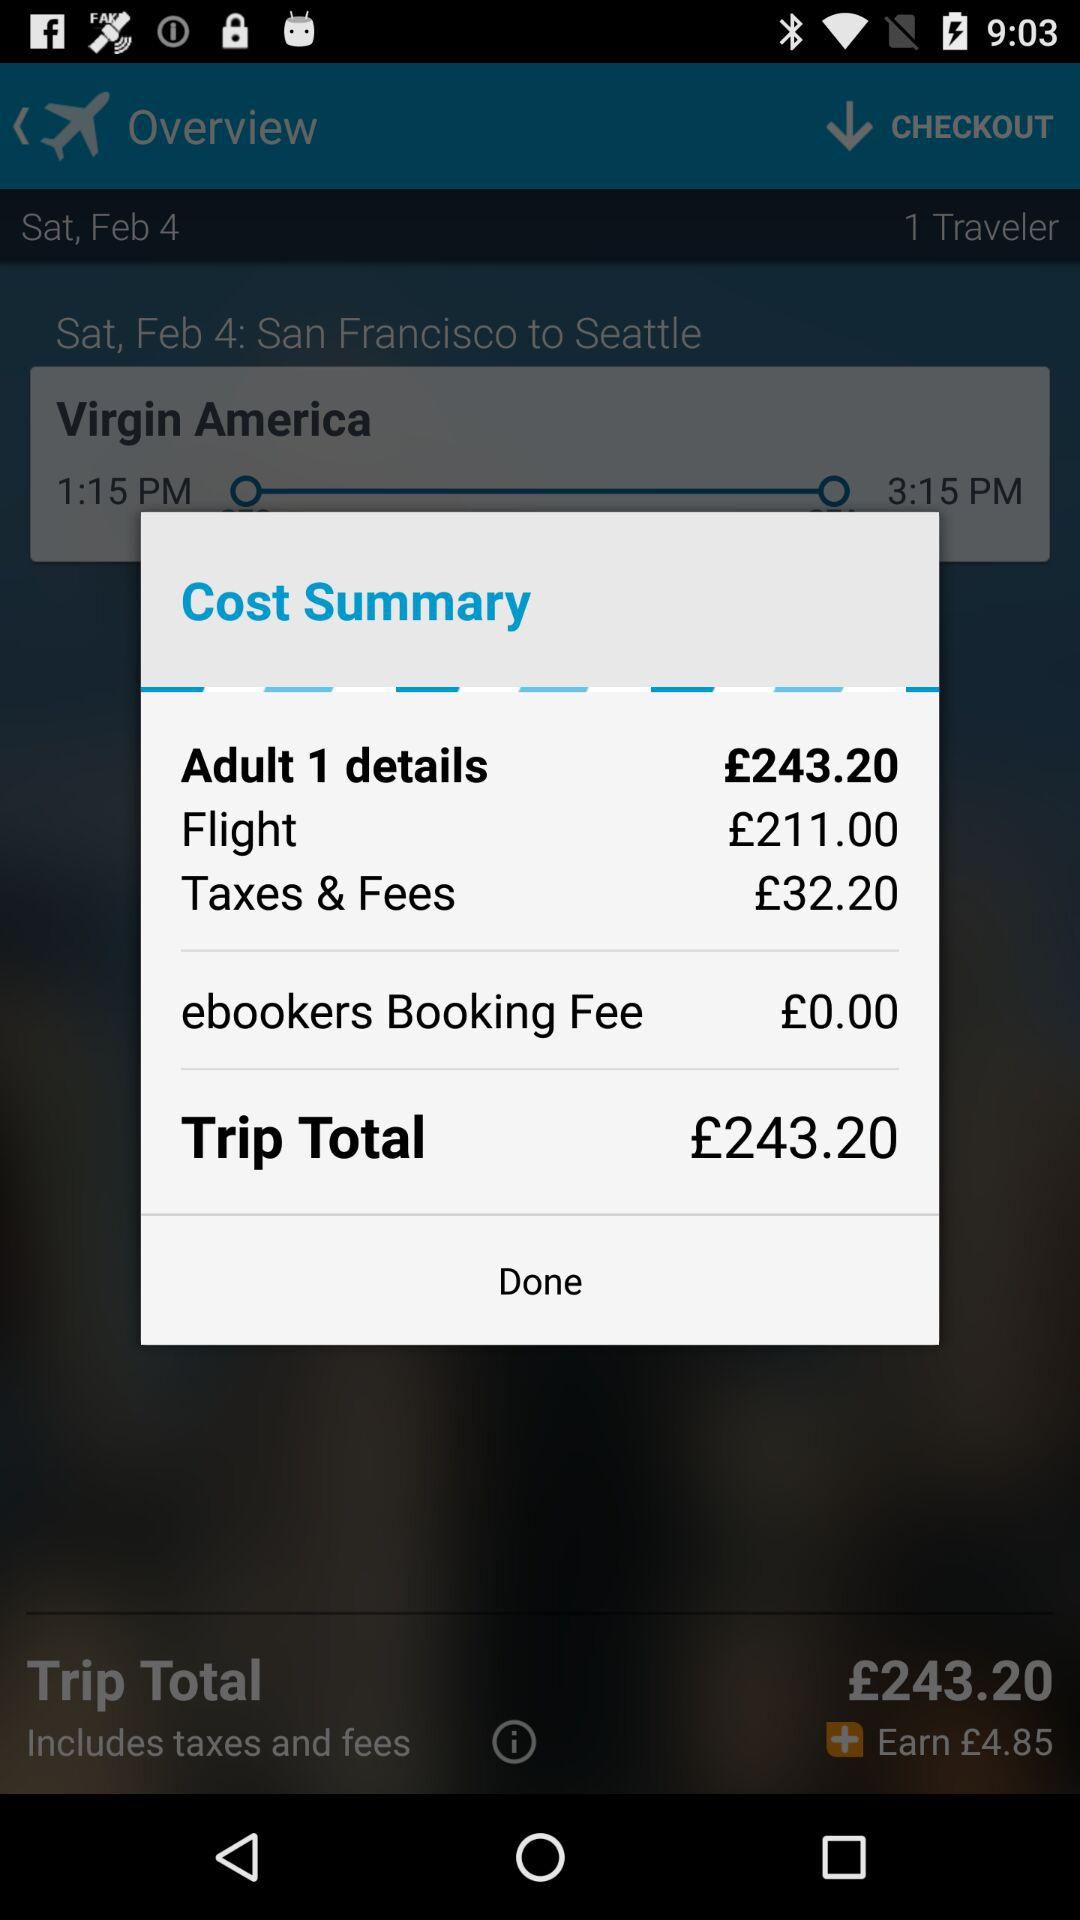How much is the flight fare for 1 adult? The flight fare for 1 adult is £211. 